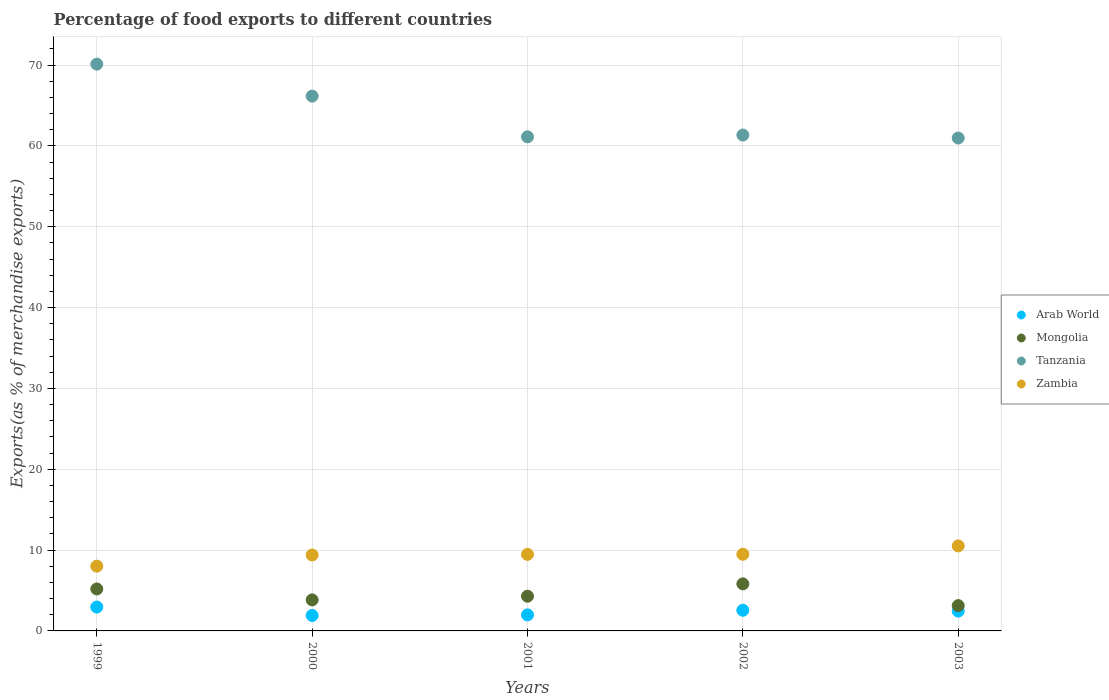How many different coloured dotlines are there?
Offer a very short reply. 4. Is the number of dotlines equal to the number of legend labels?
Give a very brief answer. Yes. What is the percentage of exports to different countries in Mongolia in 1999?
Your response must be concise. 5.19. Across all years, what is the maximum percentage of exports to different countries in Tanzania?
Ensure brevity in your answer.  70.11. Across all years, what is the minimum percentage of exports to different countries in Tanzania?
Your answer should be very brief. 60.97. In which year was the percentage of exports to different countries in Tanzania minimum?
Offer a very short reply. 2003. What is the total percentage of exports to different countries in Mongolia in the graph?
Offer a terse response. 22.28. What is the difference between the percentage of exports to different countries in Tanzania in 2000 and that in 2003?
Provide a succinct answer. 5.18. What is the difference between the percentage of exports to different countries in Mongolia in 1999 and the percentage of exports to different countries in Zambia in 2000?
Your answer should be compact. -4.2. What is the average percentage of exports to different countries in Zambia per year?
Your answer should be very brief. 9.37. In the year 2000, what is the difference between the percentage of exports to different countries in Mongolia and percentage of exports to different countries in Arab World?
Offer a terse response. 1.93. In how many years, is the percentage of exports to different countries in Arab World greater than 8 %?
Provide a succinct answer. 0. What is the ratio of the percentage of exports to different countries in Zambia in 1999 to that in 2002?
Offer a terse response. 0.84. Is the difference between the percentage of exports to different countries in Mongolia in 2001 and 2003 greater than the difference between the percentage of exports to different countries in Arab World in 2001 and 2003?
Your answer should be very brief. Yes. What is the difference between the highest and the second highest percentage of exports to different countries in Tanzania?
Keep it short and to the point. 3.95. What is the difference between the highest and the lowest percentage of exports to different countries in Zambia?
Your response must be concise. 2.5. Is the sum of the percentage of exports to different countries in Arab World in 2001 and 2003 greater than the maximum percentage of exports to different countries in Zambia across all years?
Give a very brief answer. No. Is it the case that in every year, the sum of the percentage of exports to different countries in Tanzania and percentage of exports to different countries in Arab World  is greater than the sum of percentage of exports to different countries in Zambia and percentage of exports to different countries in Mongolia?
Offer a very short reply. Yes. Is it the case that in every year, the sum of the percentage of exports to different countries in Tanzania and percentage of exports to different countries in Zambia  is greater than the percentage of exports to different countries in Arab World?
Ensure brevity in your answer.  Yes. Does the percentage of exports to different countries in Mongolia monotonically increase over the years?
Your answer should be very brief. No. Is the percentage of exports to different countries in Arab World strictly greater than the percentage of exports to different countries in Zambia over the years?
Your response must be concise. No. Is the percentage of exports to different countries in Arab World strictly less than the percentage of exports to different countries in Zambia over the years?
Your answer should be very brief. Yes. How many years are there in the graph?
Your answer should be very brief. 5. Does the graph contain any zero values?
Offer a very short reply. No. How many legend labels are there?
Offer a very short reply. 4. How are the legend labels stacked?
Provide a succinct answer. Vertical. What is the title of the graph?
Offer a very short reply. Percentage of food exports to different countries. What is the label or title of the Y-axis?
Keep it short and to the point. Exports(as % of merchandise exports). What is the Exports(as % of merchandise exports) in Arab World in 1999?
Your answer should be very brief. 2.95. What is the Exports(as % of merchandise exports) of Mongolia in 1999?
Offer a terse response. 5.19. What is the Exports(as % of merchandise exports) in Tanzania in 1999?
Give a very brief answer. 70.11. What is the Exports(as % of merchandise exports) of Zambia in 1999?
Your answer should be very brief. 8.01. What is the Exports(as % of merchandise exports) in Arab World in 2000?
Your answer should be compact. 1.91. What is the Exports(as % of merchandise exports) in Mongolia in 2000?
Your answer should be compact. 3.84. What is the Exports(as % of merchandise exports) in Tanzania in 2000?
Give a very brief answer. 66.16. What is the Exports(as % of merchandise exports) of Zambia in 2000?
Your answer should be compact. 9.39. What is the Exports(as % of merchandise exports) in Arab World in 2001?
Make the answer very short. 1.99. What is the Exports(as % of merchandise exports) in Mongolia in 2001?
Offer a very short reply. 4.29. What is the Exports(as % of merchandise exports) of Tanzania in 2001?
Keep it short and to the point. 61.12. What is the Exports(as % of merchandise exports) in Zambia in 2001?
Your answer should be very brief. 9.47. What is the Exports(as % of merchandise exports) in Arab World in 2002?
Your answer should be very brief. 2.56. What is the Exports(as % of merchandise exports) in Mongolia in 2002?
Offer a terse response. 5.82. What is the Exports(as % of merchandise exports) in Tanzania in 2002?
Your answer should be compact. 61.34. What is the Exports(as % of merchandise exports) of Zambia in 2002?
Ensure brevity in your answer.  9.48. What is the Exports(as % of merchandise exports) of Arab World in 2003?
Your answer should be very brief. 2.45. What is the Exports(as % of merchandise exports) of Mongolia in 2003?
Ensure brevity in your answer.  3.13. What is the Exports(as % of merchandise exports) of Tanzania in 2003?
Provide a succinct answer. 60.97. What is the Exports(as % of merchandise exports) of Zambia in 2003?
Give a very brief answer. 10.52. Across all years, what is the maximum Exports(as % of merchandise exports) in Arab World?
Make the answer very short. 2.95. Across all years, what is the maximum Exports(as % of merchandise exports) of Mongolia?
Offer a terse response. 5.82. Across all years, what is the maximum Exports(as % of merchandise exports) of Tanzania?
Offer a terse response. 70.11. Across all years, what is the maximum Exports(as % of merchandise exports) in Zambia?
Make the answer very short. 10.52. Across all years, what is the minimum Exports(as % of merchandise exports) in Arab World?
Your response must be concise. 1.91. Across all years, what is the minimum Exports(as % of merchandise exports) in Mongolia?
Your response must be concise. 3.13. Across all years, what is the minimum Exports(as % of merchandise exports) in Tanzania?
Provide a short and direct response. 60.97. Across all years, what is the minimum Exports(as % of merchandise exports) in Zambia?
Provide a succinct answer. 8.01. What is the total Exports(as % of merchandise exports) in Arab World in the graph?
Your response must be concise. 11.85. What is the total Exports(as % of merchandise exports) of Mongolia in the graph?
Your response must be concise. 22.28. What is the total Exports(as % of merchandise exports) of Tanzania in the graph?
Provide a succinct answer. 319.71. What is the total Exports(as % of merchandise exports) of Zambia in the graph?
Your response must be concise. 46.87. What is the difference between the Exports(as % of merchandise exports) in Arab World in 1999 and that in 2000?
Provide a short and direct response. 1.04. What is the difference between the Exports(as % of merchandise exports) in Mongolia in 1999 and that in 2000?
Your answer should be very brief. 1.35. What is the difference between the Exports(as % of merchandise exports) in Tanzania in 1999 and that in 2000?
Keep it short and to the point. 3.95. What is the difference between the Exports(as % of merchandise exports) in Zambia in 1999 and that in 2000?
Offer a terse response. -1.38. What is the difference between the Exports(as % of merchandise exports) in Arab World in 1999 and that in 2001?
Provide a succinct answer. 0.97. What is the difference between the Exports(as % of merchandise exports) of Mongolia in 1999 and that in 2001?
Provide a succinct answer. 0.9. What is the difference between the Exports(as % of merchandise exports) of Tanzania in 1999 and that in 2001?
Provide a short and direct response. 8.99. What is the difference between the Exports(as % of merchandise exports) in Zambia in 1999 and that in 2001?
Offer a very short reply. -1.46. What is the difference between the Exports(as % of merchandise exports) in Arab World in 1999 and that in 2002?
Provide a succinct answer. 0.4. What is the difference between the Exports(as % of merchandise exports) in Mongolia in 1999 and that in 2002?
Provide a succinct answer. -0.63. What is the difference between the Exports(as % of merchandise exports) of Tanzania in 1999 and that in 2002?
Make the answer very short. 8.77. What is the difference between the Exports(as % of merchandise exports) of Zambia in 1999 and that in 2002?
Keep it short and to the point. -1.47. What is the difference between the Exports(as % of merchandise exports) of Arab World in 1999 and that in 2003?
Your answer should be compact. 0.5. What is the difference between the Exports(as % of merchandise exports) of Mongolia in 1999 and that in 2003?
Provide a short and direct response. 2.06. What is the difference between the Exports(as % of merchandise exports) of Tanzania in 1999 and that in 2003?
Offer a very short reply. 9.14. What is the difference between the Exports(as % of merchandise exports) in Zambia in 1999 and that in 2003?
Your answer should be compact. -2.5. What is the difference between the Exports(as % of merchandise exports) in Arab World in 2000 and that in 2001?
Provide a succinct answer. -0.08. What is the difference between the Exports(as % of merchandise exports) of Mongolia in 2000 and that in 2001?
Ensure brevity in your answer.  -0.45. What is the difference between the Exports(as % of merchandise exports) of Tanzania in 2000 and that in 2001?
Keep it short and to the point. 5.04. What is the difference between the Exports(as % of merchandise exports) in Zambia in 2000 and that in 2001?
Your response must be concise. -0.08. What is the difference between the Exports(as % of merchandise exports) of Arab World in 2000 and that in 2002?
Your answer should be compact. -0.65. What is the difference between the Exports(as % of merchandise exports) of Mongolia in 2000 and that in 2002?
Your answer should be compact. -1.98. What is the difference between the Exports(as % of merchandise exports) of Tanzania in 2000 and that in 2002?
Keep it short and to the point. 4.82. What is the difference between the Exports(as % of merchandise exports) of Zambia in 2000 and that in 2002?
Your answer should be compact. -0.09. What is the difference between the Exports(as % of merchandise exports) in Arab World in 2000 and that in 2003?
Your response must be concise. -0.54. What is the difference between the Exports(as % of merchandise exports) in Mongolia in 2000 and that in 2003?
Keep it short and to the point. 0.71. What is the difference between the Exports(as % of merchandise exports) in Tanzania in 2000 and that in 2003?
Make the answer very short. 5.18. What is the difference between the Exports(as % of merchandise exports) in Zambia in 2000 and that in 2003?
Give a very brief answer. -1.12. What is the difference between the Exports(as % of merchandise exports) of Arab World in 2001 and that in 2002?
Give a very brief answer. -0.57. What is the difference between the Exports(as % of merchandise exports) in Mongolia in 2001 and that in 2002?
Provide a short and direct response. -1.53. What is the difference between the Exports(as % of merchandise exports) in Tanzania in 2001 and that in 2002?
Offer a terse response. -0.22. What is the difference between the Exports(as % of merchandise exports) in Zambia in 2001 and that in 2002?
Offer a terse response. -0.01. What is the difference between the Exports(as % of merchandise exports) in Arab World in 2001 and that in 2003?
Offer a terse response. -0.47. What is the difference between the Exports(as % of merchandise exports) of Mongolia in 2001 and that in 2003?
Ensure brevity in your answer.  1.16. What is the difference between the Exports(as % of merchandise exports) in Tanzania in 2001 and that in 2003?
Keep it short and to the point. 0.15. What is the difference between the Exports(as % of merchandise exports) of Zambia in 2001 and that in 2003?
Offer a very short reply. -1.05. What is the difference between the Exports(as % of merchandise exports) of Arab World in 2002 and that in 2003?
Keep it short and to the point. 0.1. What is the difference between the Exports(as % of merchandise exports) of Mongolia in 2002 and that in 2003?
Give a very brief answer. 2.69. What is the difference between the Exports(as % of merchandise exports) of Tanzania in 2002 and that in 2003?
Your answer should be very brief. 0.37. What is the difference between the Exports(as % of merchandise exports) of Zambia in 2002 and that in 2003?
Offer a very short reply. -1.03. What is the difference between the Exports(as % of merchandise exports) in Arab World in 1999 and the Exports(as % of merchandise exports) in Mongolia in 2000?
Give a very brief answer. -0.89. What is the difference between the Exports(as % of merchandise exports) of Arab World in 1999 and the Exports(as % of merchandise exports) of Tanzania in 2000?
Your response must be concise. -63.21. What is the difference between the Exports(as % of merchandise exports) in Arab World in 1999 and the Exports(as % of merchandise exports) in Zambia in 2000?
Ensure brevity in your answer.  -6.44. What is the difference between the Exports(as % of merchandise exports) in Mongolia in 1999 and the Exports(as % of merchandise exports) in Tanzania in 2000?
Offer a terse response. -60.97. What is the difference between the Exports(as % of merchandise exports) in Mongolia in 1999 and the Exports(as % of merchandise exports) in Zambia in 2000?
Offer a terse response. -4.2. What is the difference between the Exports(as % of merchandise exports) of Tanzania in 1999 and the Exports(as % of merchandise exports) of Zambia in 2000?
Keep it short and to the point. 60.72. What is the difference between the Exports(as % of merchandise exports) in Arab World in 1999 and the Exports(as % of merchandise exports) in Mongolia in 2001?
Ensure brevity in your answer.  -1.34. What is the difference between the Exports(as % of merchandise exports) in Arab World in 1999 and the Exports(as % of merchandise exports) in Tanzania in 2001?
Provide a short and direct response. -58.17. What is the difference between the Exports(as % of merchandise exports) in Arab World in 1999 and the Exports(as % of merchandise exports) in Zambia in 2001?
Offer a terse response. -6.52. What is the difference between the Exports(as % of merchandise exports) of Mongolia in 1999 and the Exports(as % of merchandise exports) of Tanzania in 2001?
Offer a terse response. -55.93. What is the difference between the Exports(as % of merchandise exports) of Mongolia in 1999 and the Exports(as % of merchandise exports) of Zambia in 2001?
Make the answer very short. -4.28. What is the difference between the Exports(as % of merchandise exports) in Tanzania in 1999 and the Exports(as % of merchandise exports) in Zambia in 2001?
Keep it short and to the point. 60.64. What is the difference between the Exports(as % of merchandise exports) of Arab World in 1999 and the Exports(as % of merchandise exports) of Mongolia in 2002?
Offer a terse response. -2.87. What is the difference between the Exports(as % of merchandise exports) of Arab World in 1999 and the Exports(as % of merchandise exports) of Tanzania in 2002?
Keep it short and to the point. -58.39. What is the difference between the Exports(as % of merchandise exports) in Arab World in 1999 and the Exports(as % of merchandise exports) in Zambia in 2002?
Your response must be concise. -6.53. What is the difference between the Exports(as % of merchandise exports) of Mongolia in 1999 and the Exports(as % of merchandise exports) of Tanzania in 2002?
Keep it short and to the point. -56.15. What is the difference between the Exports(as % of merchandise exports) in Mongolia in 1999 and the Exports(as % of merchandise exports) in Zambia in 2002?
Offer a very short reply. -4.29. What is the difference between the Exports(as % of merchandise exports) in Tanzania in 1999 and the Exports(as % of merchandise exports) in Zambia in 2002?
Give a very brief answer. 60.63. What is the difference between the Exports(as % of merchandise exports) of Arab World in 1999 and the Exports(as % of merchandise exports) of Mongolia in 2003?
Your answer should be compact. -0.18. What is the difference between the Exports(as % of merchandise exports) in Arab World in 1999 and the Exports(as % of merchandise exports) in Tanzania in 2003?
Ensure brevity in your answer.  -58.02. What is the difference between the Exports(as % of merchandise exports) of Arab World in 1999 and the Exports(as % of merchandise exports) of Zambia in 2003?
Give a very brief answer. -7.56. What is the difference between the Exports(as % of merchandise exports) of Mongolia in 1999 and the Exports(as % of merchandise exports) of Tanzania in 2003?
Your answer should be compact. -55.78. What is the difference between the Exports(as % of merchandise exports) of Mongolia in 1999 and the Exports(as % of merchandise exports) of Zambia in 2003?
Offer a terse response. -5.32. What is the difference between the Exports(as % of merchandise exports) of Tanzania in 1999 and the Exports(as % of merchandise exports) of Zambia in 2003?
Give a very brief answer. 59.6. What is the difference between the Exports(as % of merchandise exports) of Arab World in 2000 and the Exports(as % of merchandise exports) of Mongolia in 2001?
Offer a very short reply. -2.38. What is the difference between the Exports(as % of merchandise exports) of Arab World in 2000 and the Exports(as % of merchandise exports) of Tanzania in 2001?
Give a very brief answer. -59.21. What is the difference between the Exports(as % of merchandise exports) of Arab World in 2000 and the Exports(as % of merchandise exports) of Zambia in 2001?
Your answer should be very brief. -7.56. What is the difference between the Exports(as % of merchandise exports) in Mongolia in 2000 and the Exports(as % of merchandise exports) in Tanzania in 2001?
Keep it short and to the point. -57.28. What is the difference between the Exports(as % of merchandise exports) in Mongolia in 2000 and the Exports(as % of merchandise exports) in Zambia in 2001?
Offer a terse response. -5.63. What is the difference between the Exports(as % of merchandise exports) in Tanzania in 2000 and the Exports(as % of merchandise exports) in Zambia in 2001?
Your answer should be compact. 56.69. What is the difference between the Exports(as % of merchandise exports) of Arab World in 2000 and the Exports(as % of merchandise exports) of Mongolia in 2002?
Ensure brevity in your answer.  -3.91. What is the difference between the Exports(as % of merchandise exports) of Arab World in 2000 and the Exports(as % of merchandise exports) of Tanzania in 2002?
Offer a very short reply. -59.43. What is the difference between the Exports(as % of merchandise exports) of Arab World in 2000 and the Exports(as % of merchandise exports) of Zambia in 2002?
Give a very brief answer. -7.57. What is the difference between the Exports(as % of merchandise exports) of Mongolia in 2000 and the Exports(as % of merchandise exports) of Tanzania in 2002?
Give a very brief answer. -57.5. What is the difference between the Exports(as % of merchandise exports) in Mongolia in 2000 and the Exports(as % of merchandise exports) in Zambia in 2002?
Ensure brevity in your answer.  -5.64. What is the difference between the Exports(as % of merchandise exports) of Tanzania in 2000 and the Exports(as % of merchandise exports) of Zambia in 2002?
Your answer should be very brief. 56.68. What is the difference between the Exports(as % of merchandise exports) of Arab World in 2000 and the Exports(as % of merchandise exports) of Mongolia in 2003?
Provide a short and direct response. -1.22. What is the difference between the Exports(as % of merchandise exports) of Arab World in 2000 and the Exports(as % of merchandise exports) of Tanzania in 2003?
Give a very brief answer. -59.06. What is the difference between the Exports(as % of merchandise exports) in Arab World in 2000 and the Exports(as % of merchandise exports) in Zambia in 2003?
Your answer should be compact. -8.61. What is the difference between the Exports(as % of merchandise exports) in Mongolia in 2000 and the Exports(as % of merchandise exports) in Tanzania in 2003?
Ensure brevity in your answer.  -57.13. What is the difference between the Exports(as % of merchandise exports) of Mongolia in 2000 and the Exports(as % of merchandise exports) of Zambia in 2003?
Give a very brief answer. -6.68. What is the difference between the Exports(as % of merchandise exports) of Tanzania in 2000 and the Exports(as % of merchandise exports) of Zambia in 2003?
Offer a terse response. 55.64. What is the difference between the Exports(as % of merchandise exports) in Arab World in 2001 and the Exports(as % of merchandise exports) in Mongolia in 2002?
Make the answer very short. -3.83. What is the difference between the Exports(as % of merchandise exports) in Arab World in 2001 and the Exports(as % of merchandise exports) in Tanzania in 2002?
Give a very brief answer. -59.36. What is the difference between the Exports(as % of merchandise exports) of Arab World in 2001 and the Exports(as % of merchandise exports) of Zambia in 2002?
Offer a very short reply. -7.5. What is the difference between the Exports(as % of merchandise exports) of Mongolia in 2001 and the Exports(as % of merchandise exports) of Tanzania in 2002?
Give a very brief answer. -57.05. What is the difference between the Exports(as % of merchandise exports) of Mongolia in 2001 and the Exports(as % of merchandise exports) of Zambia in 2002?
Your response must be concise. -5.19. What is the difference between the Exports(as % of merchandise exports) in Tanzania in 2001 and the Exports(as % of merchandise exports) in Zambia in 2002?
Offer a very short reply. 51.64. What is the difference between the Exports(as % of merchandise exports) in Arab World in 2001 and the Exports(as % of merchandise exports) in Mongolia in 2003?
Your answer should be compact. -1.14. What is the difference between the Exports(as % of merchandise exports) in Arab World in 2001 and the Exports(as % of merchandise exports) in Tanzania in 2003?
Give a very brief answer. -58.99. What is the difference between the Exports(as % of merchandise exports) of Arab World in 2001 and the Exports(as % of merchandise exports) of Zambia in 2003?
Keep it short and to the point. -8.53. What is the difference between the Exports(as % of merchandise exports) of Mongolia in 2001 and the Exports(as % of merchandise exports) of Tanzania in 2003?
Offer a very short reply. -56.68. What is the difference between the Exports(as % of merchandise exports) of Mongolia in 2001 and the Exports(as % of merchandise exports) of Zambia in 2003?
Your answer should be compact. -6.22. What is the difference between the Exports(as % of merchandise exports) in Tanzania in 2001 and the Exports(as % of merchandise exports) in Zambia in 2003?
Offer a very short reply. 50.6. What is the difference between the Exports(as % of merchandise exports) in Arab World in 2002 and the Exports(as % of merchandise exports) in Mongolia in 2003?
Your response must be concise. -0.57. What is the difference between the Exports(as % of merchandise exports) in Arab World in 2002 and the Exports(as % of merchandise exports) in Tanzania in 2003?
Your response must be concise. -58.42. What is the difference between the Exports(as % of merchandise exports) in Arab World in 2002 and the Exports(as % of merchandise exports) in Zambia in 2003?
Offer a terse response. -7.96. What is the difference between the Exports(as % of merchandise exports) in Mongolia in 2002 and the Exports(as % of merchandise exports) in Tanzania in 2003?
Ensure brevity in your answer.  -55.15. What is the difference between the Exports(as % of merchandise exports) in Mongolia in 2002 and the Exports(as % of merchandise exports) in Zambia in 2003?
Give a very brief answer. -4.7. What is the difference between the Exports(as % of merchandise exports) in Tanzania in 2002 and the Exports(as % of merchandise exports) in Zambia in 2003?
Offer a terse response. 50.83. What is the average Exports(as % of merchandise exports) of Arab World per year?
Your answer should be very brief. 2.37. What is the average Exports(as % of merchandise exports) in Mongolia per year?
Make the answer very short. 4.46. What is the average Exports(as % of merchandise exports) of Tanzania per year?
Provide a short and direct response. 63.94. What is the average Exports(as % of merchandise exports) of Zambia per year?
Your response must be concise. 9.37. In the year 1999, what is the difference between the Exports(as % of merchandise exports) of Arab World and Exports(as % of merchandise exports) of Mongolia?
Give a very brief answer. -2.24. In the year 1999, what is the difference between the Exports(as % of merchandise exports) of Arab World and Exports(as % of merchandise exports) of Tanzania?
Your answer should be compact. -67.16. In the year 1999, what is the difference between the Exports(as % of merchandise exports) of Arab World and Exports(as % of merchandise exports) of Zambia?
Provide a succinct answer. -5.06. In the year 1999, what is the difference between the Exports(as % of merchandise exports) of Mongolia and Exports(as % of merchandise exports) of Tanzania?
Your response must be concise. -64.92. In the year 1999, what is the difference between the Exports(as % of merchandise exports) in Mongolia and Exports(as % of merchandise exports) in Zambia?
Offer a very short reply. -2.82. In the year 1999, what is the difference between the Exports(as % of merchandise exports) of Tanzania and Exports(as % of merchandise exports) of Zambia?
Your response must be concise. 62.1. In the year 2000, what is the difference between the Exports(as % of merchandise exports) of Arab World and Exports(as % of merchandise exports) of Mongolia?
Make the answer very short. -1.93. In the year 2000, what is the difference between the Exports(as % of merchandise exports) in Arab World and Exports(as % of merchandise exports) in Tanzania?
Offer a very short reply. -64.25. In the year 2000, what is the difference between the Exports(as % of merchandise exports) in Arab World and Exports(as % of merchandise exports) in Zambia?
Make the answer very short. -7.48. In the year 2000, what is the difference between the Exports(as % of merchandise exports) of Mongolia and Exports(as % of merchandise exports) of Tanzania?
Keep it short and to the point. -62.32. In the year 2000, what is the difference between the Exports(as % of merchandise exports) in Mongolia and Exports(as % of merchandise exports) in Zambia?
Give a very brief answer. -5.55. In the year 2000, what is the difference between the Exports(as % of merchandise exports) in Tanzania and Exports(as % of merchandise exports) in Zambia?
Make the answer very short. 56.77. In the year 2001, what is the difference between the Exports(as % of merchandise exports) of Arab World and Exports(as % of merchandise exports) of Mongolia?
Your answer should be compact. -2.31. In the year 2001, what is the difference between the Exports(as % of merchandise exports) of Arab World and Exports(as % of merchandise exports) of Tanzania?
Your response must be concise. -59.13. In the year 2001, what is the difference between the Exports(as % of merchandise exports) of Arab World and Exports(as % of merchandise exports) of Zambia?
Make the answer very short. -7.48. In the year 2001, what is the difference between the Exports(as % of merchandise exports) in Mongolia and Exports(as % of merchandise exports) in Tanzania?
Your answer should be very brief. -56.83. In the year 2001, what is the difference between the Exports(as % of merchandise exports) in Mongolia and Exports(as % of merchandise exports) in Zambia?
Ensure brevity in your answer.  -5.18. In the year 2001, what is the difference between the Exports(as % of merchandise exports) of Tanzania and Exports(as % of merchandise exports) of Zambia?
Your answer should be very brief. 51.65. In the year 2002, what is the difference between the Exports(as % of merchandise exports) in Arab World and Exports(as % of merchandise exports) in Mongolia?
Make the answer very short. -3.26. In the year 2002, what is the difference between the Exports(as % of merchandise exports) in Arab World and Exports(as % of merchandise exports) in Tanzania?
Give a very brief answer. -58.79. In the year 2002, what is the difference between the Exports(as % of merchandise exports) in Arab World and Exports(as % of merchandise exports) in Zambia?
Give a very brief answer. -6.93. In the year 2002, what is the difference between the Exports(as % of merchandise exports) in Mongolia and Exports(as % of merchandise exports) in Tanzania?
Keep it short and to the point. -55.52. In the year 2002, what is the difference between the Exports(as % of merchandise exports) in Mongolia and Exports(as % of merchandise exports) in Zambia?
Make the answer very short. -3.66. In the year 2002, what is the difference between the Exports(as % of merchandise exports) in Tanzania and Exports(as % of merchandise exports) in Zambia?
Offer a terse response. 51.86. In the year 2003, what is the difference between the Exports(as % of merchandise exports) of Arab World and Exports(as % of merchandise exports) of Mongolia?
Make the answer very short. -0.68. In the year 2003, what is the difference between the Exports(as % of merchandise exports) of Arab World and Exports(as % of merchandise exports) of Tanzania?
Ensure brevity in your answer.  -58.52. In the year 2003, what is the difference between the Exports(as % of merchandise exports) in Arab World and Exports(as % of merchandise exports) in Zambia?
Provide a short and direct response. -8.06. In the year 2003, what is the difference between the Exports(as % of merchandise exports) of Mongolia and Exports(as % of merchandise exports) of Tanzania?
Your response must be concise. -57.84. In the year 2003, what is the difference between the Exports(as % of merchandise exports) in Mongolia and Exports(as % of merchandise exports) in Zambia?
Ensure brevity in your answer.  -7.39. In the year 2003, what is the difference between the Exports(as % of merchandise exports) in Tanzania and Exports(as % of merchandise exports) in Zambia?
Your answer should be compact. 50.46. What is the ratio of the Exports(as % of merchandise exports) of Arab World in 1999 to that in 2000?
Offer a very short reply. 1.55. What is the ratio of the Exports(as % of merchandise exports) in Mongolia in 1999 to that in 2000?
Keep it short and to the point. 1.35. What is the ratio of the Exports(as % of merchandise exports) in Tanzania in 1999 to that in 2000?
Offer a very short reply. 1.06. What is the ratio of the Exports(as % of merchandise exports) of Zambia in 1999 to that in 2000?
Your answer should be compact. 0.85. What is the ratio of the Exports(as % of merchandise exports) of Arab World in 1999 to that in 2001?
Ensure brevity in your answer.  1.49. What is the ratio of the Exports(as % of merchandise exports) of Mongolia in 1999 to that in 2001?
Make the answer very short. 1.21. What is the ratio of the Exports(as % of merchandise exports) of Tanzania in 1999 to that in 2001?
Your answer should be very brief. 1.15. What is the ratio of the Exports(as % of merchandise exports) of Zambia in 1999 to that in 2001?
Give a very brief answer. 0.85. What is the ratio of the Exports(as % of merchandise exports) in Arab World in 1999 to that in 2002?
Offer a very short reply. 1.16. What is the ratio of the Exports(as % of merchandise exports) in Mongolia in 1999 to that in 2002?
Offer a terse response. 0.89. What is the ratio of the Exports(as % of merchandise exports) in Tanzania in 1999 to that in 2002?
Offer a very short reply. 1.14. What is the ratio of the Exports(as % of merchandise exports) in Zambia in 1999 to that in 2002?
Offer a terse response. 0.84. What is the ratio of the Exports(as % of merchandise exports) of Arab World in 1999 to that in 2003?
Keep it short and to the point. 1.2. What is the ratio of the Exports(as % of merchandise exports) of Mongolia in 1999 to that in 2003?
Offer a very short reply. 1.66. What is the ratio of the Exports(as % of merchandise exports) in Tanzania in 1999 to that in 2003?
Make the answer very short. 1.15. What is the ratio of the Exports(as % of merchandise exports) in Zambia in 1999 to that in 2003?
Offer a very short reply. 0.76. What is the ratio of the Exports(as % of merchandise exports) of Arab World in 2000 to that in 2001?
Make the answer very short. 0.96. What is the ratio of the Exports(as % of merchandise exports) in Mongolia in 2000 to that in 2001?
Give a very brief answer. 0.89. What is the ratio of the Exports(as % of merchandise exports) in Tanzania in 2000 to that in 2001?
Your answer should be compact. 1.08. What is the ratio of the Exports(as % of merchandise exports) in Zambia in 2000 to that in 2001?
Provide a short and direct response. 0.99. What is the ratio of the Exports(as % of merchandise exports) in Arab World in 2000 to that in 2002?
Offer a very short reply. 0.75. What is the ratio of the Exports(as % of merchandise exports) in Mongolia in 2000 to that in 2002?
Offer a very short reply. 0.66. What is the ratio of the Exports(as % of merchandise exports) in Tanzania in 2000 to that in 2002?
Give a very brief answer. 1.08. What is the ratio of the Exports(as % of merchandise exports) in Arab World in 2000 to that in 2003?
Your answer should be very brief. 0.78. What is the ratio of the Exports(as % of merchandise exports) in Mongolia in 2000 to that in 2003?
Your response must be concise. 1.23. What is the ratio of the Exports(as % of merchandise exports) of Tanzania in 2000 to that in 2003?
Offer a very short reply. 1.08. What is the ratio of the Exports(as % of merchandise exports) of Zambia in 2000 to that in 2003?
Your answer should be very brief. 0.89. What is the ratio of the Exports(as % of merchandise exports) of Arab World in 2001 to that in 2002?
Your answer should be compact. 0.78. What is the ratio of the Exports(as % of merchandise exports) in Mongolia in 2001 to that in 2002?
Provide a succinct answer. 0.74. What is the ratio of the Exports(as % of merchandise exports) of Tanzania in 2001 to that in 2002?
Ensure brevity in your answer.  1. What is the ratio of the Exports(as % of merchandise exports) of Zambia in 2001 to that in 2002?
Provide a succinct answer. 1. What is the ratio of the Exports(as % of merchandise exports) in Arab World in 2001 to that in 2003?
Provide a short and direct response. 0.81. What is the ratio of the Exports(as % of merchandise exports) in Mongolia in 2001 to that in 2003?
Provide a short and direct response. 1.37. What is the ratio of the Exports(as % of merchandise exports) of Tanzania in 2001 to that in 2003?
Keep it short and to the point. 1. What is the ratio of the Exports(as % of merchandise exports) of Zambia in 2001 to that in 2003?
Provide a succinct answer. 0.9. What is the ratio of the Exports(as % of merchandise exports) in Arab World in 2002 to that in 2003?
Make the answer very short. 1.04. What is the ratio of the Exports(as % of merchandise exports) in Mongolia in 2002 to that in 2003?
Keep it short and to the point. 1.86. What is the ratio of the Exports(as % of merchandise exports) of Zambia in 2002 to that in 2003?
Provide a succinct answer. 0.9. What is the difference between the highest and the second highest Exports(as % of merchandise exports) in Arab World?
Your response must be concise. 0.4. What is the difference between the highest and the second highest Exports(as % of merchandise exports) in Mongolia?
Provide a succinct answer. 0.63. What is the difference between the highest and the second highest Exports(as % of merchandise exports) of Tanzania?
Make the answer very short. 3.95. What is the difference between the highest and the second highest Exports(as % of merchandise exports) of Zambia?
Offer a terse response. 1.03. What is the difference between the highest and the lowest Exports(as % of merchandise exports) of Arab World?
Make the answer very short. 1.04. What is the difference between the highest and the lowest Exports(as % of merchandise exports) in Mongolia?
Provide a succinct answer. 2.69. What is the difference between the highest and the lowest Exports(as % of merchandise exports) in Tanzania?
Make the answer very short. 9.14. What is the difference between the highest and the lowest Exports(as % of merchandise exports) of Zambia?
Keep it short and to the point. 2.5. 